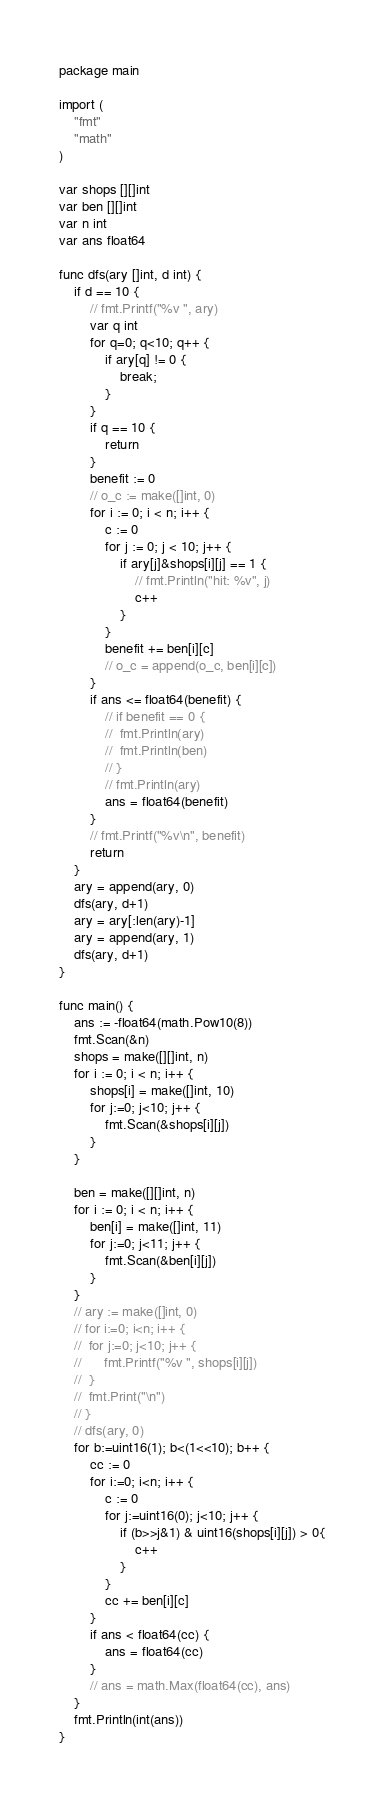Convert code to text. <code><loc_0><loc_0><loc_500><loc_500><_Go_>package main

import (
	"fmt"
	"math"
)

var shops [][]int
var ben [][]int
var n int
var ans float64

func dfs(ary []int, d int) {
	if d == 10 {
		// fmt.Printf("%v ", ary)
		var q int
		for q=0; q<10; q++ {
			if ary[q] != 0 {
				break;
			}
		}
		if q == 10 {
			return
		}
		benefit := 0
		// o_c := make([]int, 0)
		for i := 0; i < n; i++ {
			c := 0
			for j := 0; j < 10; j++ {
				if ary[j]&shops[i][j] == 1 {
					// fmt.Println("hit: %v", j)
					c++
				}
			}
			benefit += ben[i][c]
			// o_c = append(o_c, ben[i][c])
		}
		if ans <= float64(benefit) {
			// if benefit == 0 {
			// 	fmt.Println(ary)
			// 	fmt.Println(ben)
			// }
			// fmt.Println(ary)
			ans = float64(benefit)
		}
		// fmt.Printf("%v\n", benefit)
		return
	}
	ary = append(ary, 0)
	dfs(ary, d+1)
	ary = ary[:len(ary)-1]
	ary = append(ary, 1)
	dfs(ary, d+1)
}

func main() {
	ans := -float64(math.Pow10(8))
	fmt.Scan(&n)
	shops = make([][]int, n)
	for i := 0; i < n; i++ {
		shops[i] = make([]int, 10)
		for j:=0; j<10; j++ {
			fmt.Scan(&shops[i][j])
		}
	}

	ben = make([][]int, n)
	for i := 0; i < n; i++ {
		ben[i] = make([]int, 11)
		for j:=0; j<11; j++ {
			fmt.Scan(&ben[i][j])
		}
	}
	// ary := make([]int, 0)
	// for i:=0; i<n; i++ {
	// 	for j:=0; j<10; j++ {
	// 		fmt.Printf("%v ", shops[i][j])
	// 	}
	// 	fmt.Print("\n")
	// }
	// dfs(ary, 0)
	for b:=uint16(1); b<(1<<10); b++ {
		cc := 0
		for i:=0; i<n; i++ {
			c := 0
			for j:=uint16(0); j<10; j++ {
				if (b>>j&1) & uint16(shops[i][j]) > 0{
					c++
				}
			}
			cc += ben[i][c]
		}
		if ans < float64(cc) {
			ans = float64(cc)
		}
		// ans = math.Max(float64(cc), ans)
	}
	fmt.Println(int(ans))
}
</code> 